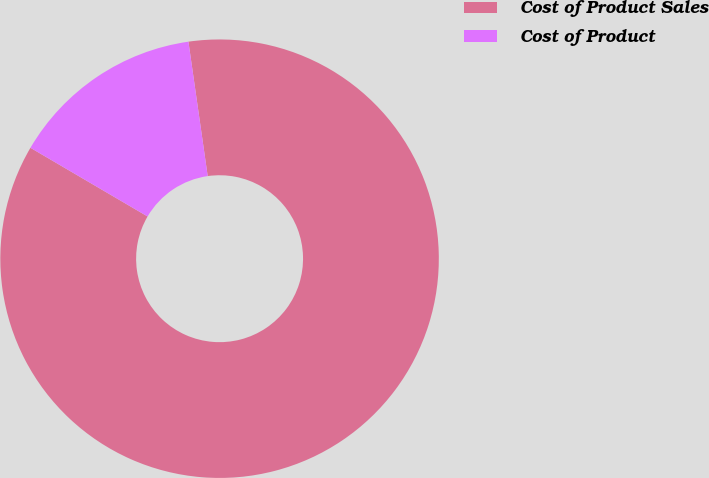Convert chart to OTSL. <chart><loc_0><loc_0><loc_500><loc_500><pie_chart><fcel>Cost of Product Sales<fcel>Cost of Product<nl><fcel>85.71%<fcel>14.29%<nl></chart> 